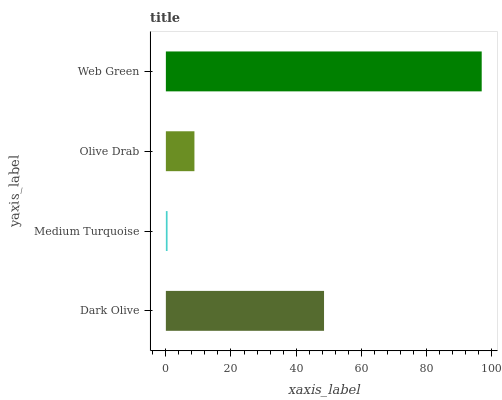Is Medium Turquoise the minimum?
Answer yes or no. Yes. Is Web Green the maximum?
Answer yes or no. Yes. Is Olive Drab the minimum?
Answer yes or no. No. Is Olive Drab the maximum?
Answer yes or no. No. Is Olive Drab greater than Medium Turquoise?
Answer yes or no. Yes. Is Medium Turquoise less than Olive Drab?
Answer yes or no. Yes. Is Medium Turquoise greater than Olive Drab?
Answer yes or no. No. Is Olive Drab less than Medium Turquoise?
Answer yes or no. No. Is Dark Olive the high median?
Answer yes or no. Yes. Is Olive Drab the low median?
Answer yes or no. Yes. Is Medium Turquoise the high median?
Answer yes or no. No. Is Web Green the low median?
Answer yes or no. No. 